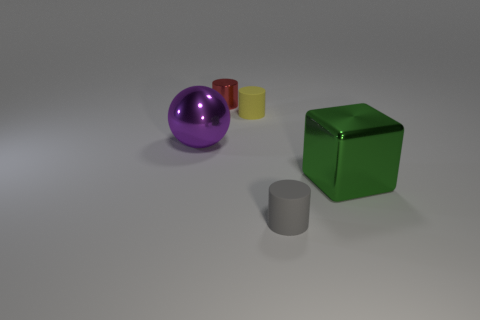Add 2 big gray shiny objects. How many objects exist? 7 Subtract all small yellow rubber cylinders. How many cylinders are left? 2 Subtract all spheres. How many objects are left? 4 Subtract 0 red spheres. How many objects are left? 5 Subtract all blue cylinders. Subtract all purple blocks. How many cylinders are left? 3 Subtract all yellow objects. Subtract all gray objects. How many objects are left? 3 Add 1 large purple things. How many large purple things are left? 2 Add 4 large purple balls. How many large purple balls exist? 5 